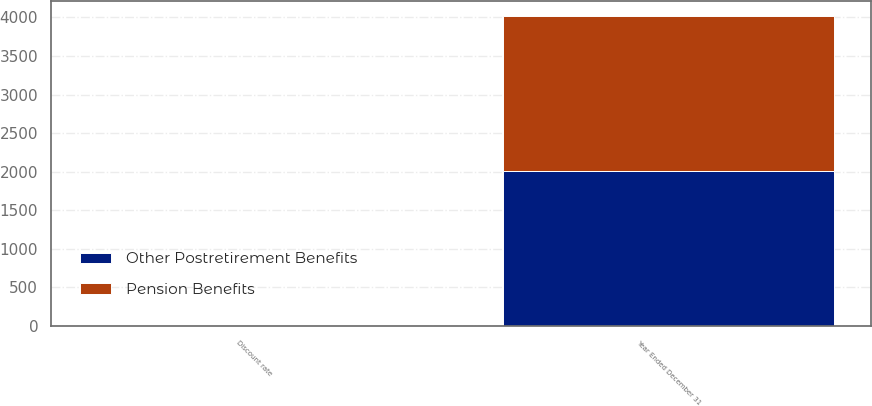<chart> <loc_0><loc_0><loc_500><loc_500><stacked_bar_chart><ecel><fcel>Year Ended December 31<fcel>Discount rate<nl><fcel>Pension Benefits<fcel>2008<fcel>6<nl><fcel>Other Postretirement Benefits<fcel>2008<fcel>5.9<nl></chart> 